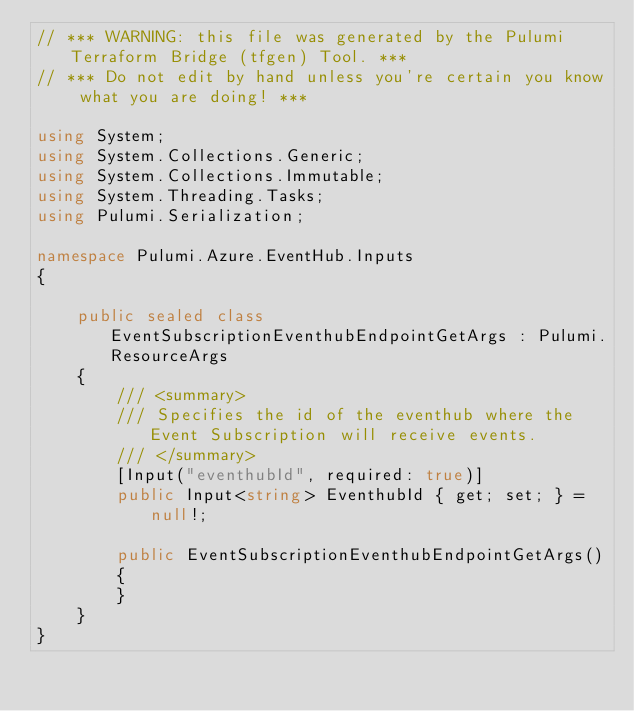Convert code to text. <code><loc_0><loc_0><loc_500><loc_500><_C#_>// *** WARNING: this file was generated by the Pulumi Terraform Bridge (tfgen) Tool. ***
// *** Do not edit by hand unless you're certain you know what you are doing! ***

using System;
using System.Collections.Generic;
using System.Collections.Immutable;
using System.Threading.Tasks;
using Pulumi.Serialization;

namespace Pulumi.Azure.EventHub.Inputs
{

    public sealed class EventSubscriptionEventhubEndpointGetArgs : Pulumi.ResourceArgs
    {
        /// <summary>
        /// Specifies the id of the eventhub where the Event Subscription will receive events.
        /// </summary>
        [Input("eventhubId", required: true)]
        public Input<string> EventhubId { get; set; } = null!;

        public EventSubscriptionEventhubEndpointGetArgs()
        {
        }
    }
}
</code> 